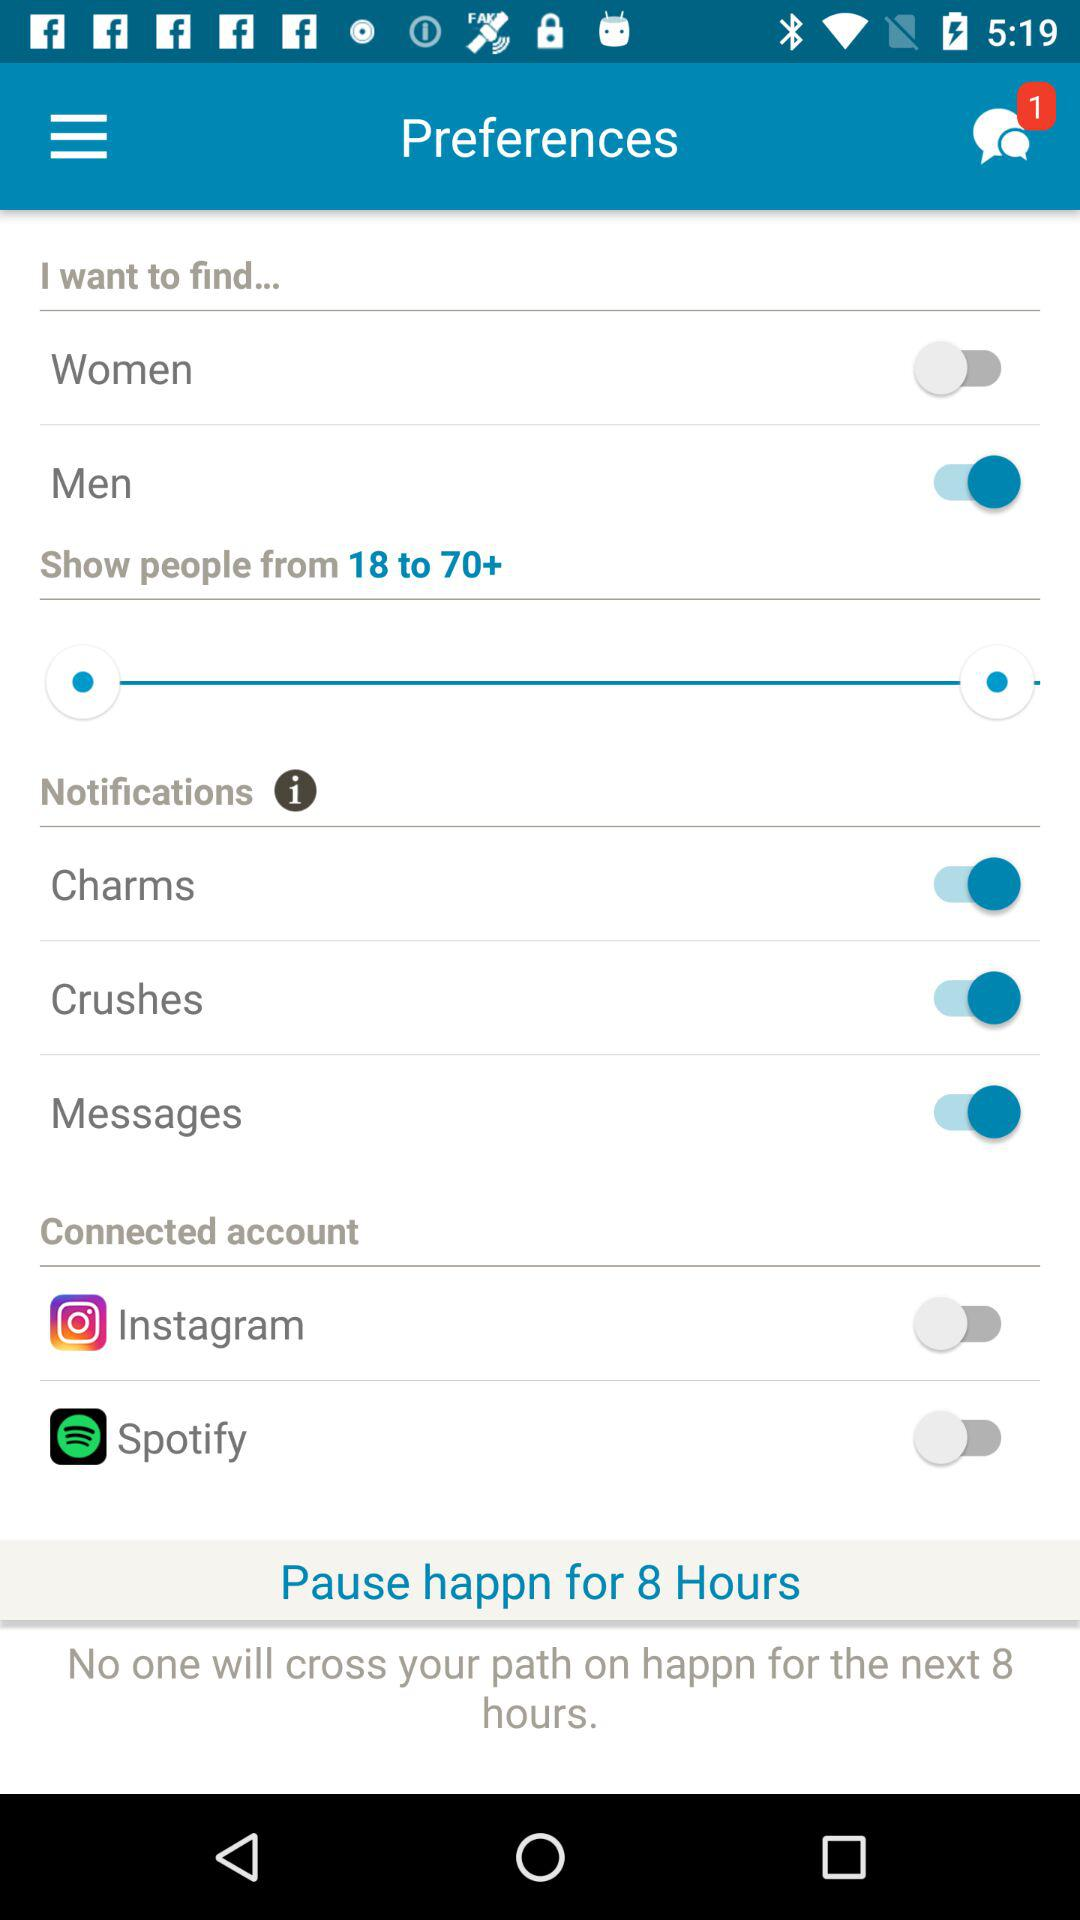What gender is selected in "I want to find..."? The selected gender is "Men". 